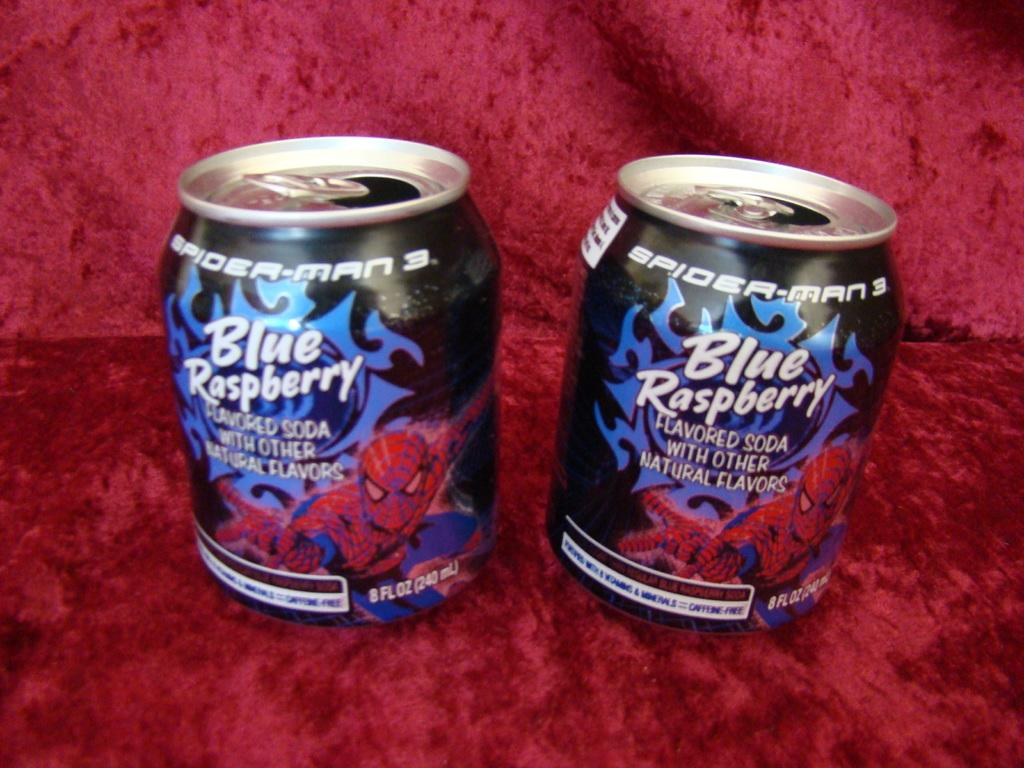<image>
Provide a brief description of the given image. a blue rasberry can that is on a red carpet 